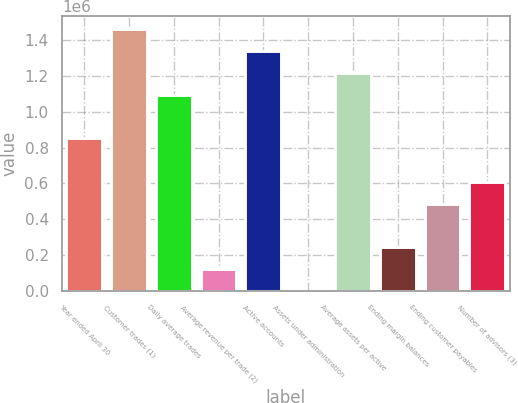Convert chart. <chart><loc_0><loc_0><loc_500><loc_500><bar_chart><fcel>Year ended April 30<fcel>Customer trades (1)<fcel>Daily average trades<fcel>Average revenue per trade (2)<fcel>Active accounts<fcel>Assets under administration<fcel>Average assets per active<fcel>Ending margin balances<fcel>Ending customer payables<fcel>Number of advisors (3)<nl><fcel>852671<fcel>1.46171e+06<fcel>1.09629e+06<fcel>121829<fcel>1.3399e+06<fcel>22.3<fcel>1.21809e+06<fcel>243636<fcel>487250<fcel>609057<nl></chart> 